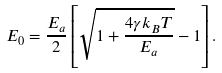Convert formula to latex. <formula><loc_0><loc_0><loc_500><loc_500>E _ { 0 } = \frac { E _ { a } } 2 \left [ \sqrt { 1 + \frac { 4 \gamma k _ { B } T } { E _ { a } } } - 1 \right ] .</formula> 